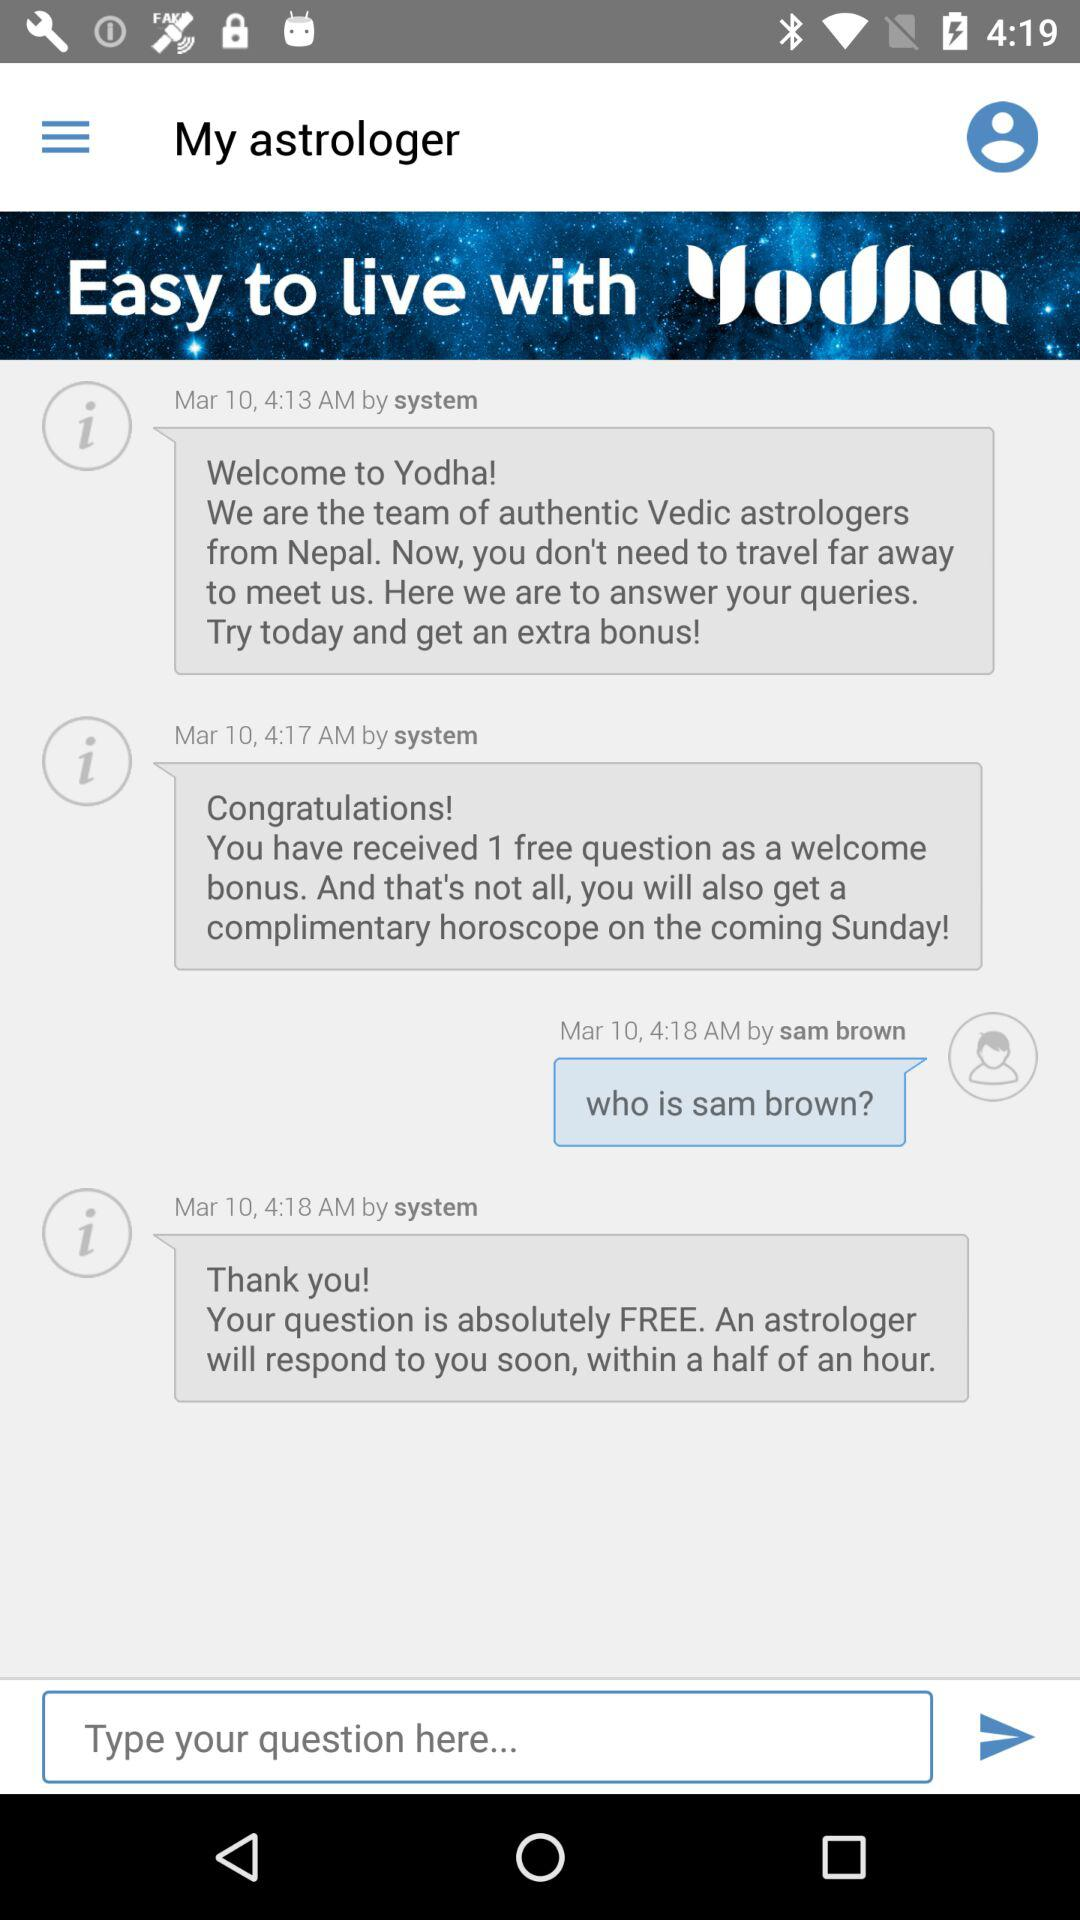What is the selected year? The selected year is 1990. 